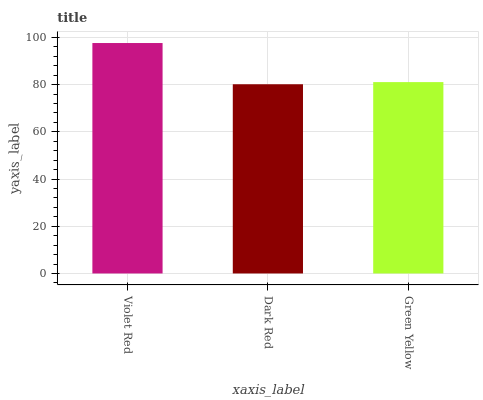Is Dark Red the minimum?
Answer yes or no. Yes. Is Violet Red the maximum?
Answer yes or no. Yes. Is Green Yellow the minimum?
Answer yes or no. No. Is Green Yellow the maximum?
Answer yes or no. No. Is Green Yellow greater than Dark Red?
Answer yes or no. Yes. Is Dark Red less than Green Yellow?
Answer yes or no. Yes. Is Dark Red greater than Green Yellow?
Answer yes or no. No. Is Green Yellow less than Dark Red?
Answer yes or no. No. Is Green Yellow the high median?
Answer yes or no. Yes. Is Green Yellow the low median?
Answer yes or no. Yes. Is Dark Red the high median?
Answer yes or no. No. Is Violet Red the low median?
Answer yes or no. No. 